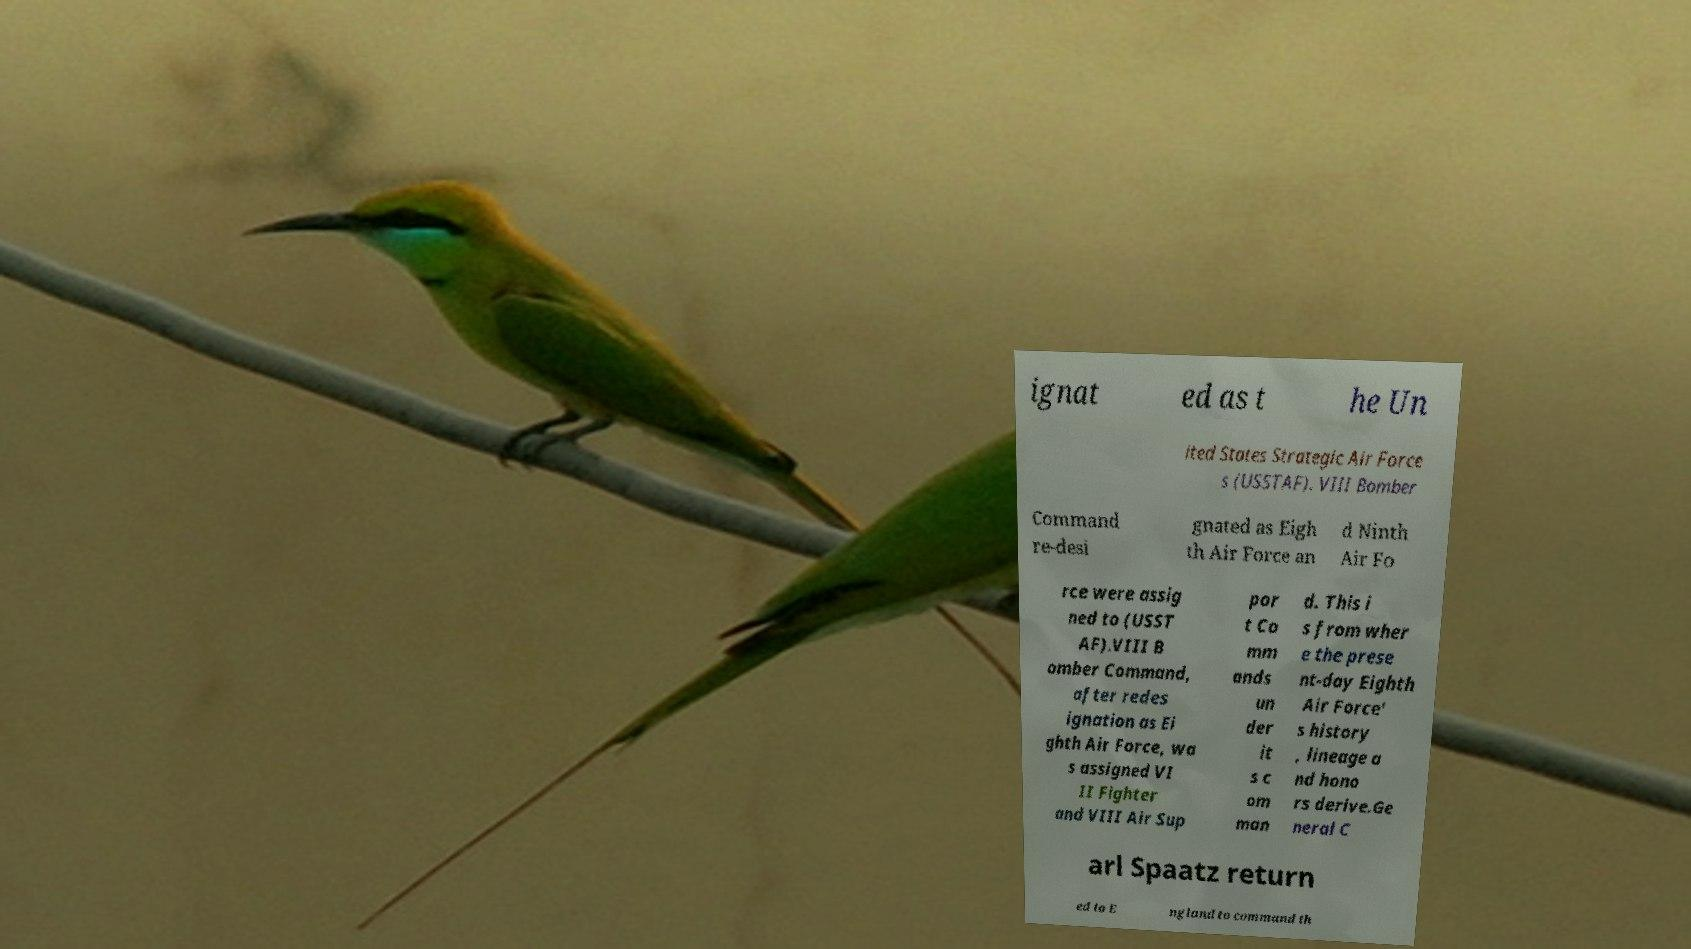There's text embedded in this image that I need extracted. Can you transcribe it verbatim? ignat ed as t he Un ited States Strategic Air Force s (USSTAF). VIII Bomber Command re-desi gnated as Eigh th Air Force an d Ninth Air Fo rce were assig ned to (USST AF).VIII B omber Command, after redes ignation as Ei ghth Air Force, wa s assigned VI II Fighter and VIII Air Sup por t Co mm ands un der it s c om man d. This i s from wher e the prese nt-day Eighth Air Force' s history , lineage a nd hono rs derive.Ge neral C arl Spaatz return ed to E ngland to command th 